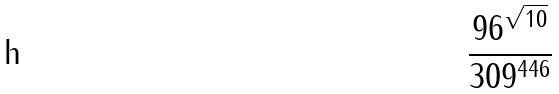<formula> <loc_0><loc_0><loc_500><loc_500>\frac { 9 6 ^ { \sqrt { 1 0 } } } { 3 0 9 ^ { 4 4 6 } }</formula> 